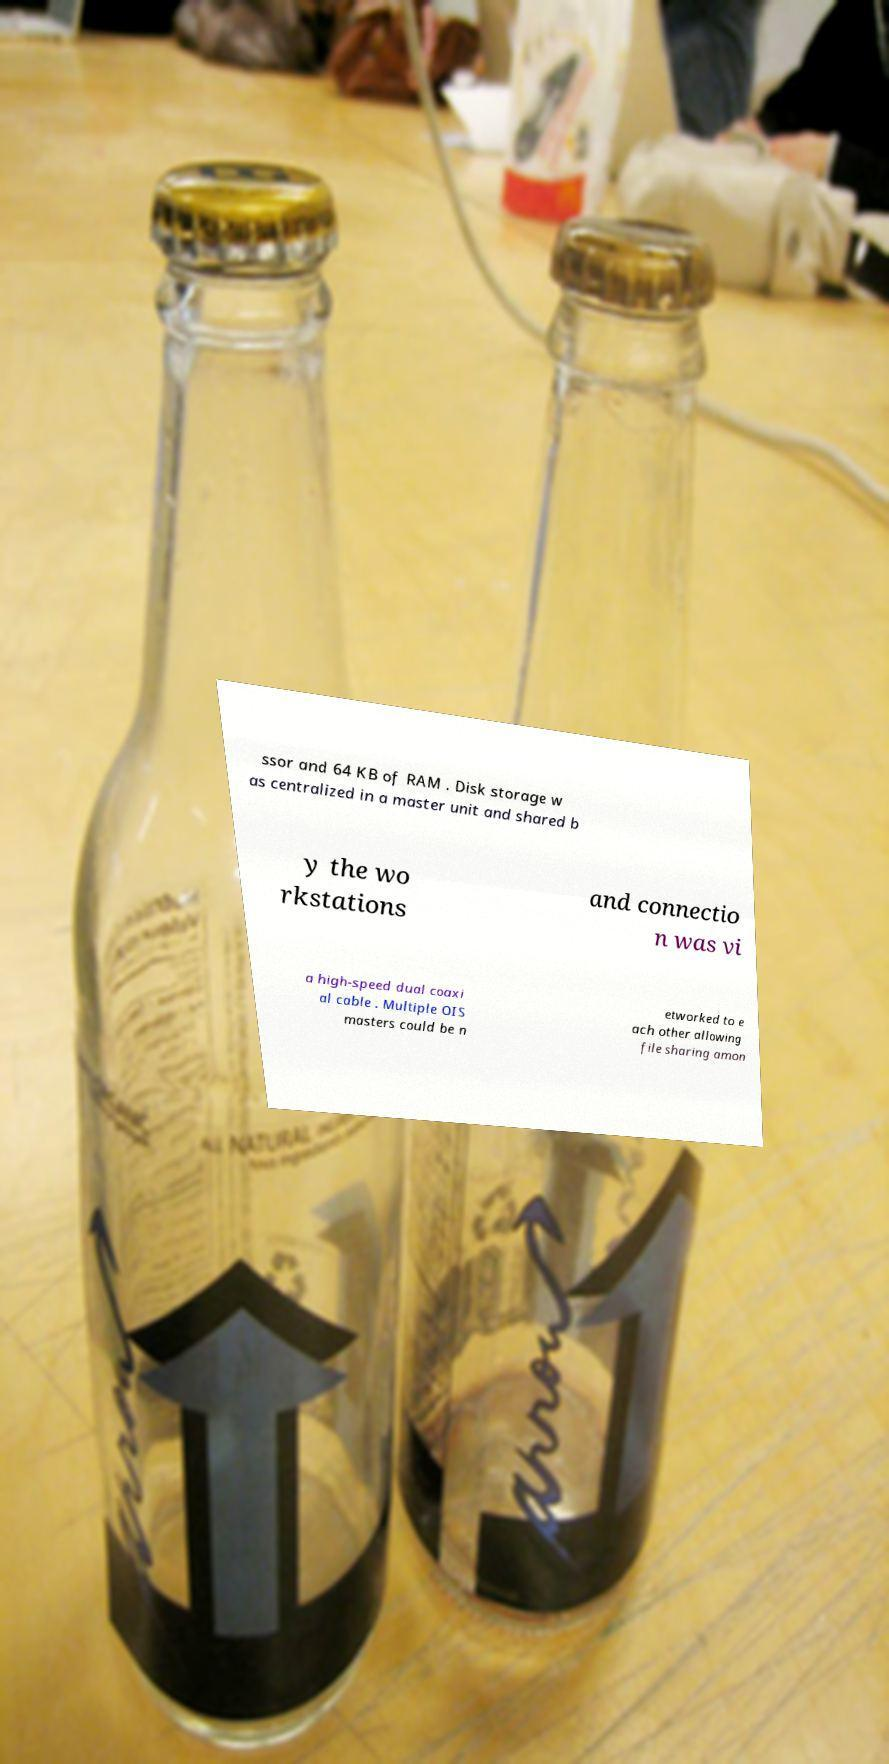What messages or text are displayed in this image? I need them in a readable, typed format. ssor and 64 KB of RAM . Disk storage w as centralized in a master unit and shared b y the wo rkstations and connectio n was vi a high-speed dual coaxi al cable . Multiple OIS masters could be n etworked to e ach other allowing file sharing amon 